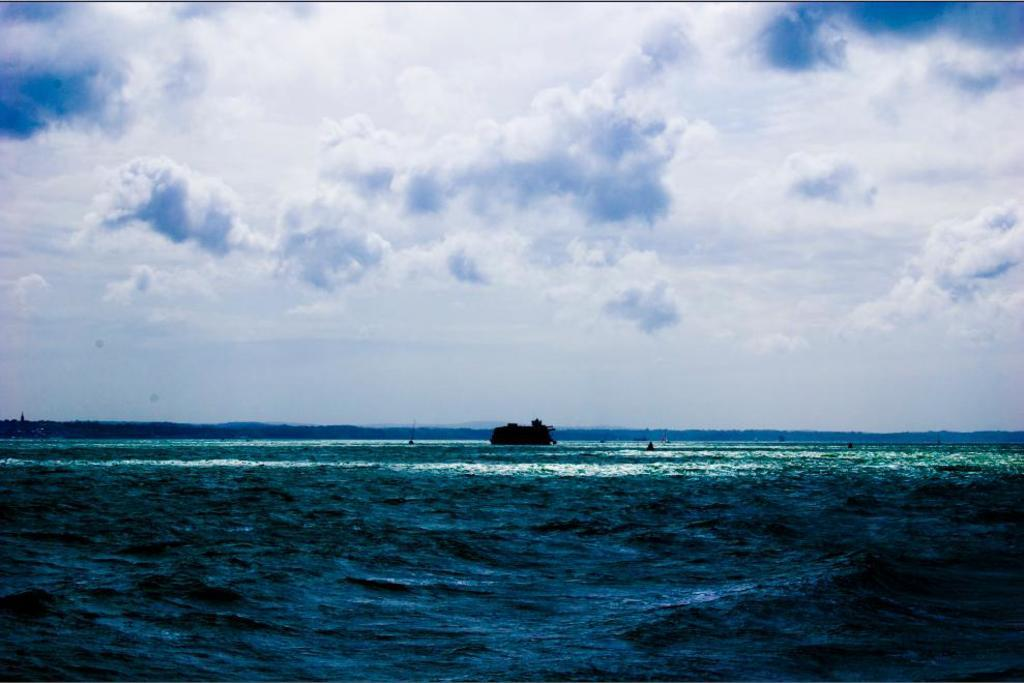What is the main subject of the image? The main subject of the image is a boat. Where is the boat located? The boat is on the water. What can be seen in the background of the image? There is a mountain in the background of the image. What is visible in the sky? There are clouds in the sky. What type of apparatus is used to bite the mountain in the image? There is no apparatus used to bite the mountain in the image, as mountains are not edible and cannot be bitten. 